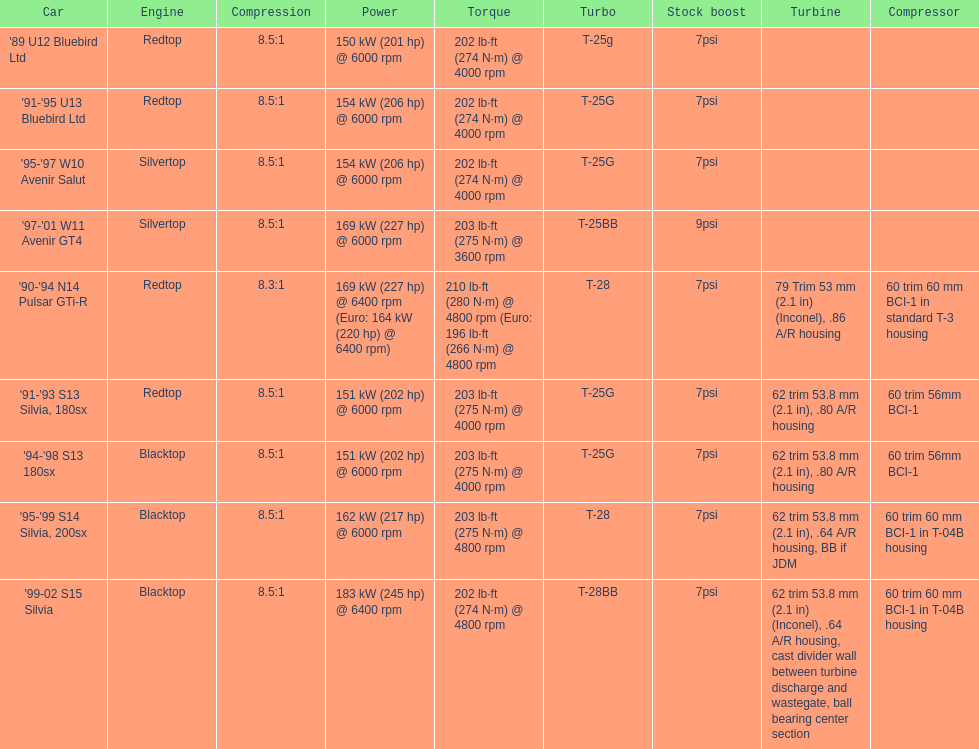What is his/her compression for the 90-94 n14 pulsar gti-r? 8.3:1. 